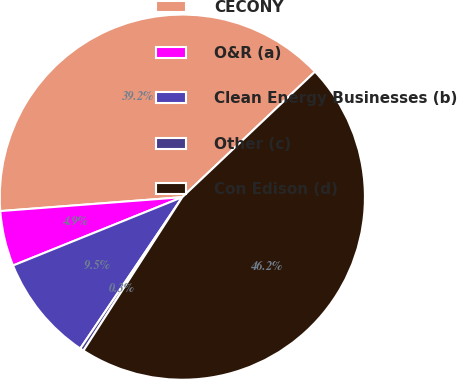Convert chart. <chart><loc_0><loc_0><loc_500><loc_500><pie_chart><fcel>CECONY<fcel>O&R (a)<fcel>Clean Energy Businesses (b)<fcel>Other (c)<fcel>Con Edison (d)<nl><fcel>39.15%<fcel>4.89%<fcel>9.45%<fcel>0.33%<fcel>46.16%<nl></chart> 